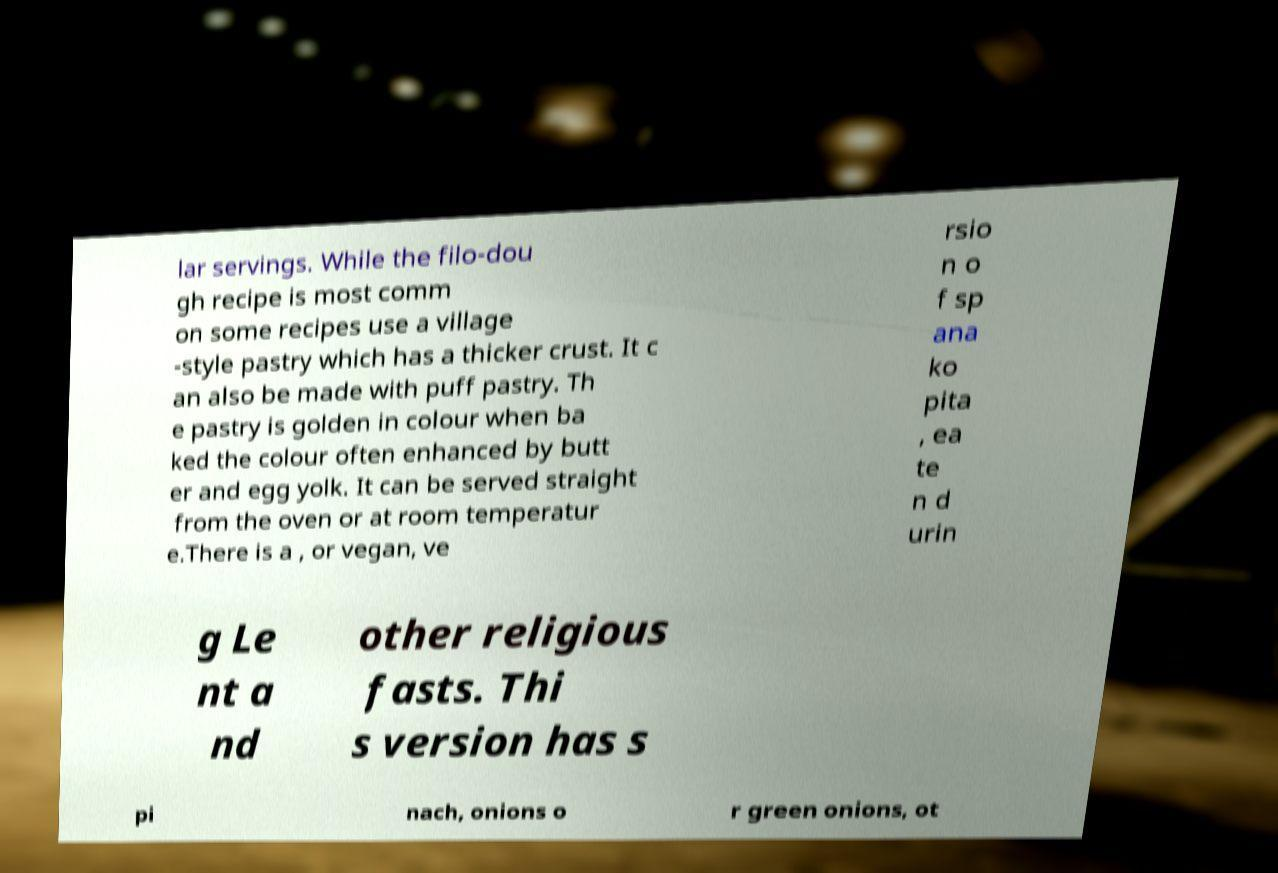Please read and relay the text visible in this image. What does it say? lar servings. While the filo-dou gh recipe is most comm on some recipes use a village -style pastry which has a thicker crust. It c an also be made with puff pastry. Th e pastry is golden in colour when ba ked the colour often enhanced by butt er and egg yolk. It can be served straight from the oven or at room temperatur e.There is a , or vegan, ve rsio n o f sp ana ko pita , ea te n d urin g Le nt a nd other religious fasts. Thi s version has s pi nach, onions o r green onions, ot 